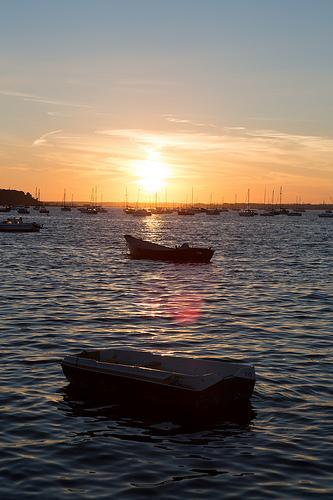Capture the essence of the image using a single sentence. In a tranquil setting, a small boat floats gently on clear blue waters as sailboats bask under an orange sunset sky. List the main features of the image in the form of a casual observation. There's a small boat near us, some sailboats in the background, a nice orange sunset, clouds in the blue sky, and clear water with the sun reflecting on it. Describe the position of the boats and the general mood of the scene in the image. A small boat floats nearest the camera with sailboats in the distance under an orange sunset, creating a serene and peaceful mood. Write a brief summary focusing on the state of the water and natural elements of the image. The water is clear and blue with small waves, reflecting the sun. The sky is blue with white clouds, and there's an orange sunset behind sailboats. Describe the main features of the image highlighting the natural beauty of the scenario. The calming blue water, orange hues of the setting sun, and the white clouds set a beautiful backdrop for the small boat and distant sailboats. Write a brief, evocative description of the image focusing on the color palette. Tones of orange and blue paint a dreamy scene, as sailboats anchor beneath a picturesque sunset on calm, crystal-clear waters. Mention the most prominent elements of the image and their colors. A small white boat, sailboats with sails down, an orange sunset, a blue sky with clouds, and a clear blue body of water with sun reflection. Narrate the key aspects of the image using the language of a poet. Upon a tranquil blue canvas, a tiny vessel lingers amidst gentle waves whilst sailboats rest beneath an enchanting orange twilight. Mention the key items in the image from the point of view of a traveler. The sun sets over sailboats on a blue body of water with clear skies and white clouds, creating an inviting and picturesque view. Write a short atmospheric description of the scene captured in the image. A serene scene unfolds as a graceful white boat drifts in the shimmering blue waters, accompanied by sailboats under the warm orange glow of a setting sun. 